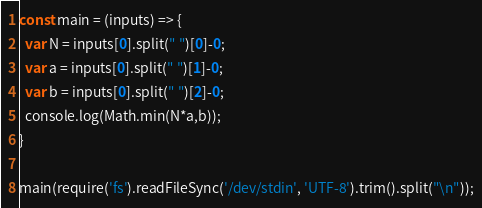Convert code to text. <code><loc_0><loc_0><loc_500><loc_500><_JavaScript_>const main = (inputs) => {
  var N = inputs[0].split(" ")[0]-0;
  var a = inputs[0].split(" ")[1]-0;
  var b = inputs[0].split(" ")[2]-0;
  console.log(Math.min(N*a,b));
}

main(require('fs').readFileSync('/dev/stdin', 'UTF-8').trim().split("\n"));
</code> 